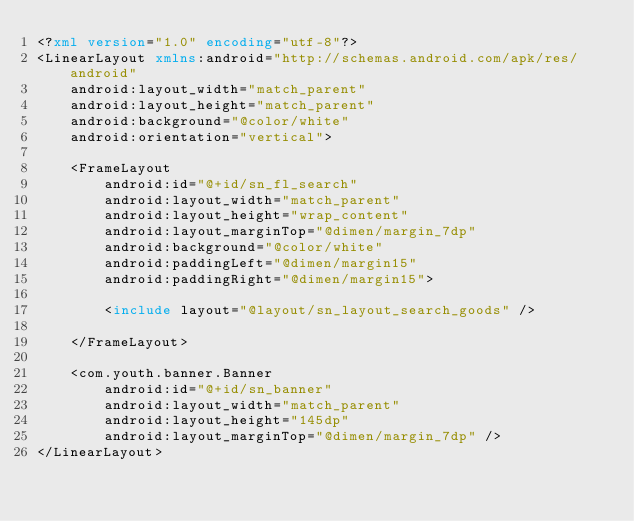<code> <loc_0><loc_0><loc_500><loc_500><_XML_><?xml version="1.0" encoding="utf-8"?>
<LinearLayout xmlns:android="http://schemas.android.com/apk/res/android"
    android:layout_width="match_parent"
    android:layout_height="match_parent"
    android:background="@color/white"
    android:orientation="vertical">

    <FrameLayout
        android:id="@+id/sn_fl_search"
        android:layout_width="match_parent"
        android:layout_height="wrap_content"
        android:layout_marginTop="@dimen/margin_7dp"
        android:background="@color/white"
        android:paddingLeft="@dimen/margin15"
        android:paddingRight="@dimen/margin15">

        <include layout="@layout/sn_layout_search_goods" />

    </FrameLayout>

    <com.youth.banner.Banner
        android:id="@+id/sn_banner"
        android:layout_width="match_parent"
        android:layout_height="145dp"
        android:layout_marginTop="@dimen/margin_7dp" />
</LinearLayout>
</code> 